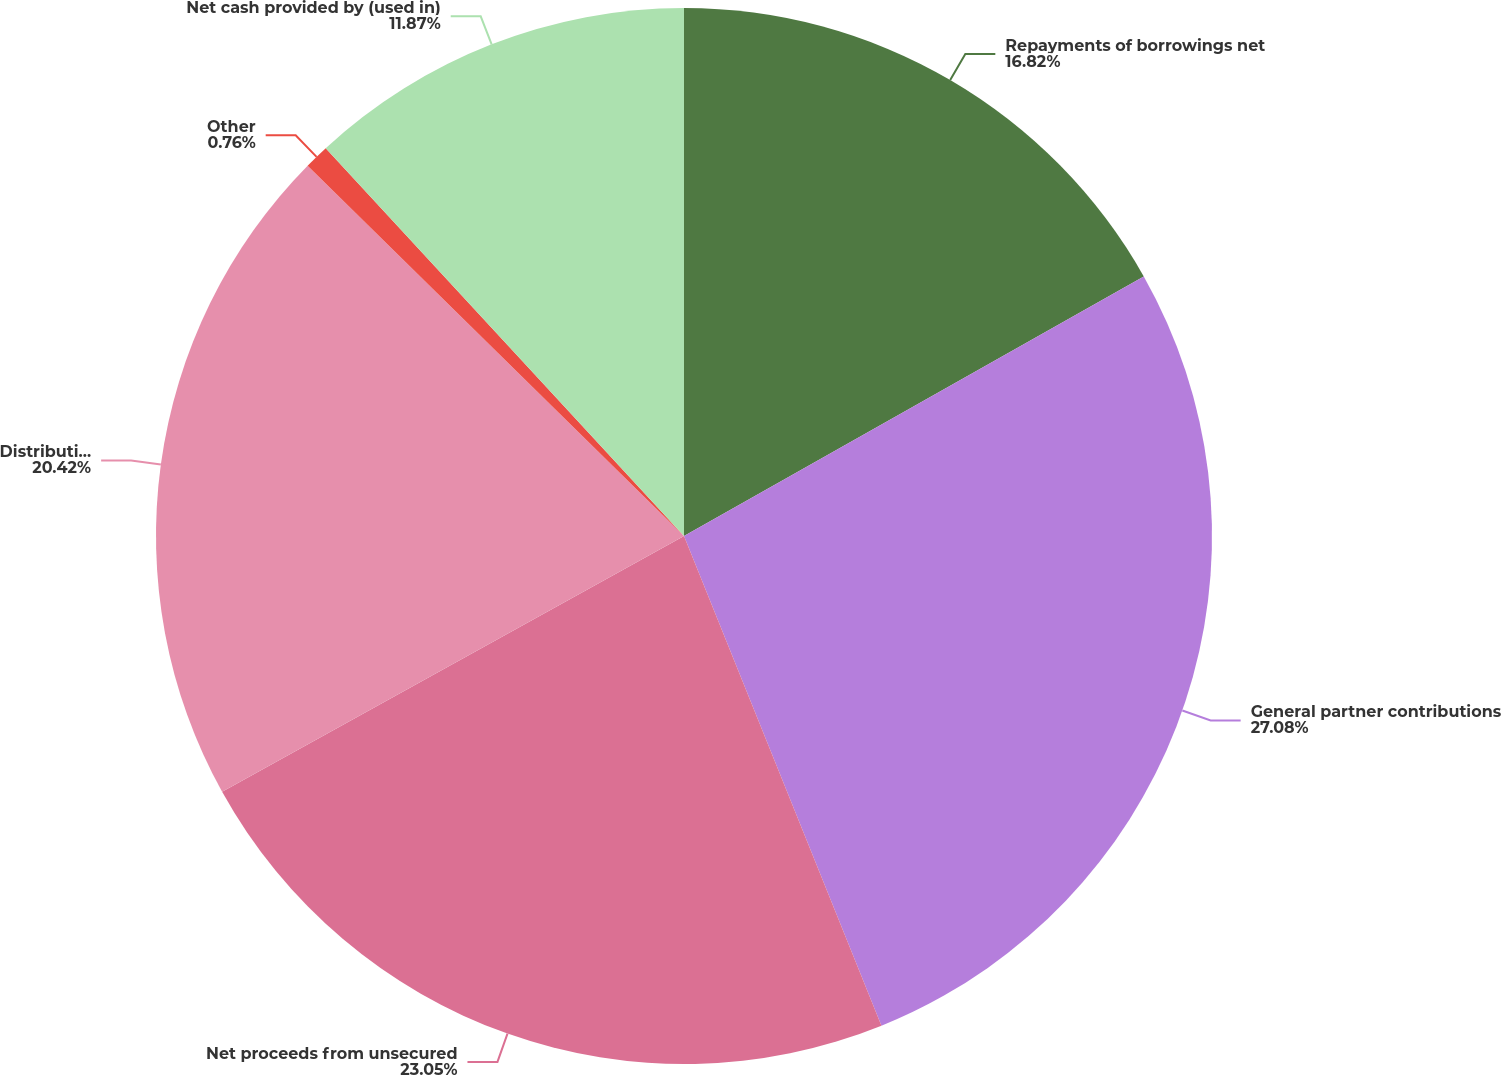Convert chart. <chart><loc_0><loc_0><loc_500><loc_500><pie_chart><fcel>Repayments of borrowings net<fcel>General partner contributions<fcel>Net proceeds from unsecured<fcel>Distribution payments<fcel>Other<fcel>Net cash provided by (used in)<nl><fcel>16.82%<fcel>27.08%<fcel>23.05%<fcel>20.42%<fcel>0.76%<fcel>11.87%<nl></chart> 